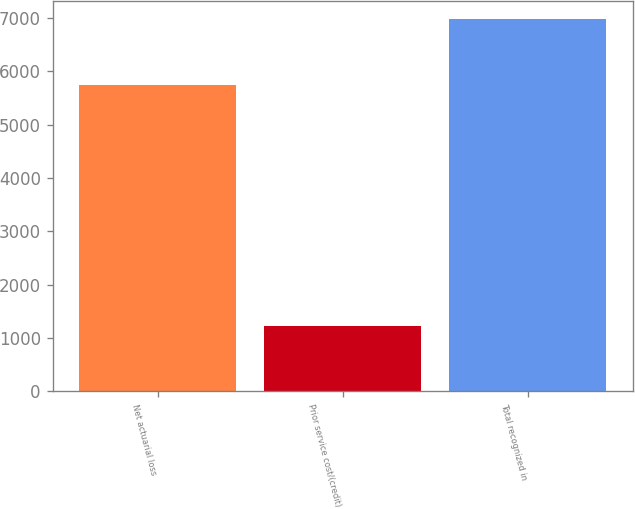Convert chart to OTSL. <chart><loc_0><loc_0><loc_500><loc_500><bar_chart><fcel>Net actuarial loss<fcel>Prior service cost/(credit)<fcel>Total recognized in<nl><fcel>5750<fcel>1219<fcel>6969<nl></chart> 